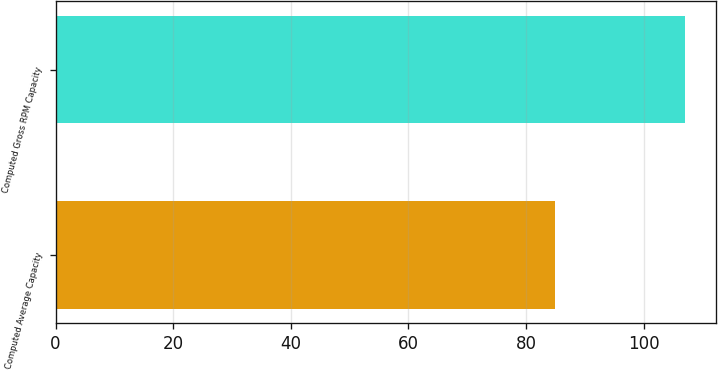Convert chart to OTSL. <chart><loc_0><loc_0><loc_500><loc_500><bar_chart><fcel>Computed Average Capacity<fcel>Computed Gross RPM Capacity<nl><fcel>85<fcel>107<nl></chart> 